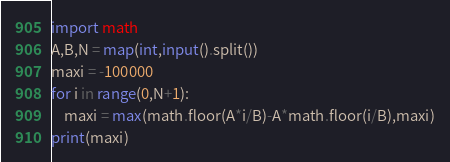Convert code to text. <code><loc_0><loc_0><loc_500><loc_500><_Python_>import math
A,B,N = map(int,input().split())
maxi = -100000
for i in range(0,N+1):
    maxi = max(math.floor(A*i/B)-A*math.floor(i/B),maxi)
print(maxi)
</code> 